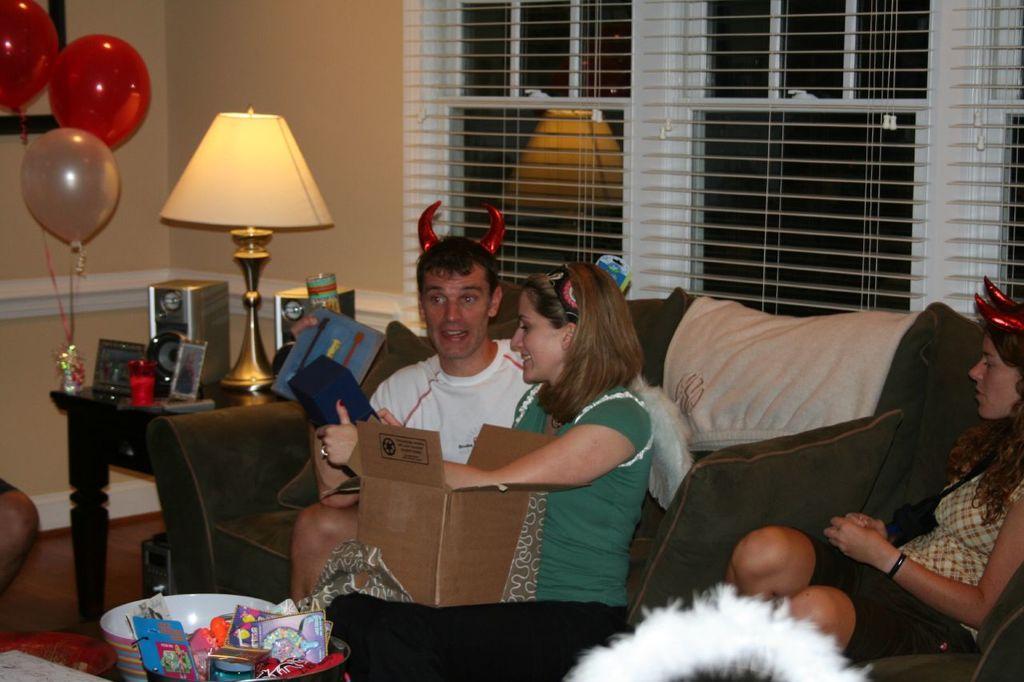Describe this image in one or two sentences. In this picture i could see three person sitting on the black colored sofa wearing a horn on there head with lady beside the person is holding a cotton box and in the corner of the table i could see a lamp holder on the table and the balloons on it and in the background i could see window with blinds. 